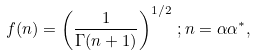<formula> <loc_0><loc_0><loc_500><loc_500>f ( n ) = \left ( \frac { 1 } { \Gamma ( n + 1 ) } \right ) ^ { 1 / 2 } \, ; n = \alpha \alpha ^ { * } ,</formula> 